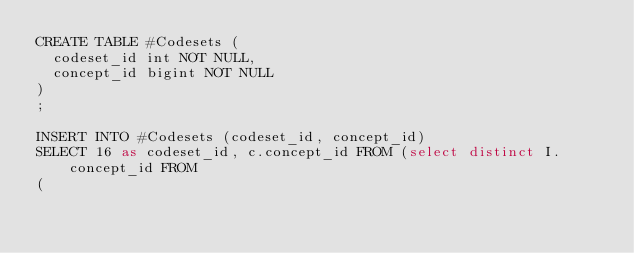<code> <loc_0><loc_0><loc_500><loc_500><_SQL_>CREATE TABLE #Codesets (
  codeset_id int NOT NULL,
  concept_id bigint NOT NULL
)
;

INSERT INTO #Codesets (codeset_id, concept_id)
SELECT 16 as codeset_id, c.concept_id FROM (select distinct I.concept_id FROM
( </code> 